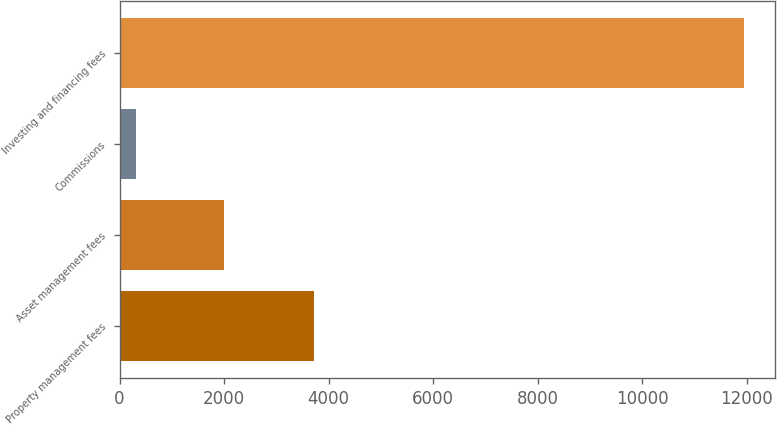Convert chart to OTSL. <chart><loc_0><loc_0><loc_500><loc_500><bar_chart><fcel>Property management fees<fcel>Asset management fees<fcel>Commissions<fcel>Investing and financing fees<nl><fcel>3719<fcel>2005<fcel>316<fcel>11948<nl></chart> 